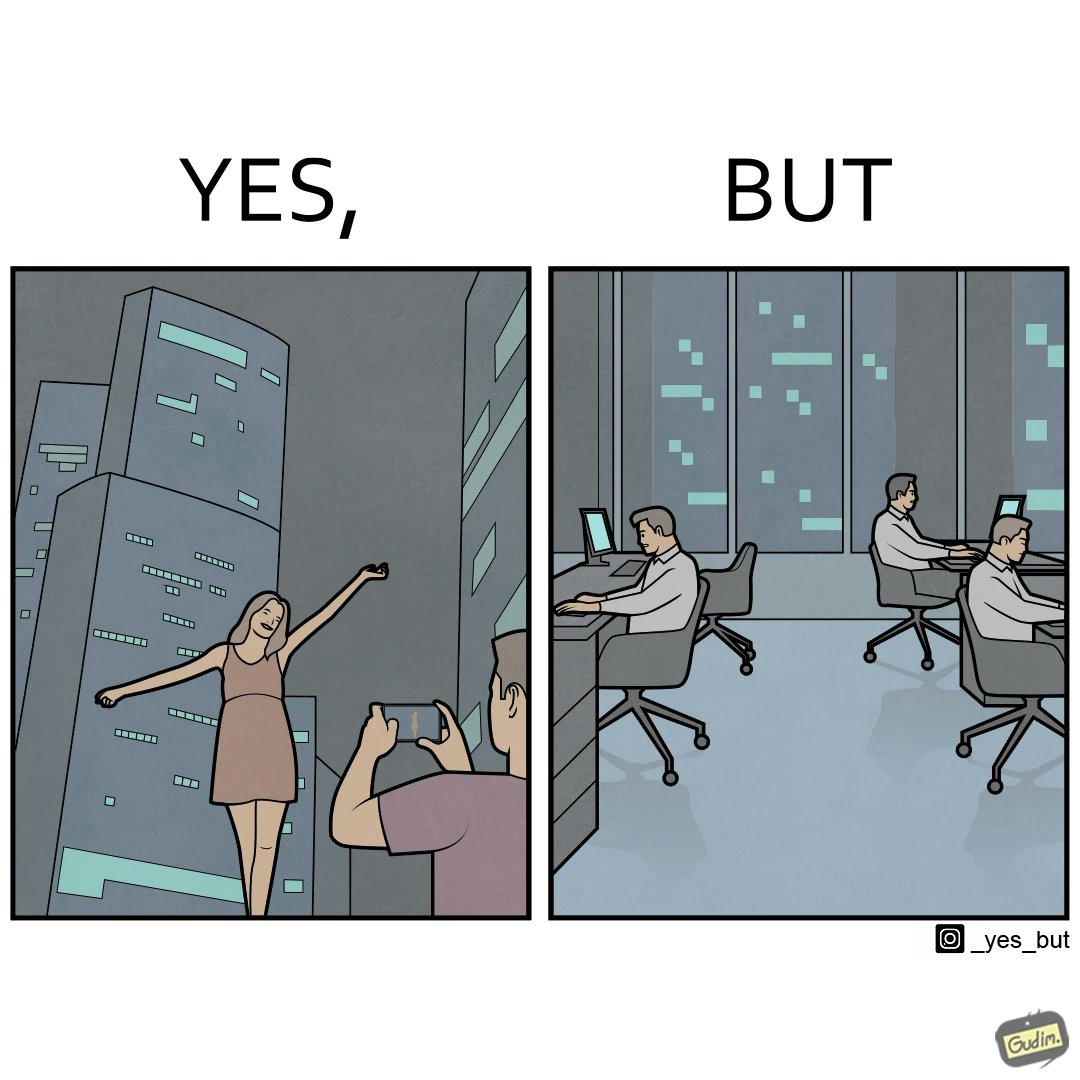Why is this image considered satirical? The images are ironic since it shows how a holiday destination for a woman and a man is actually a workplace for many others where they are toiling away everyday 